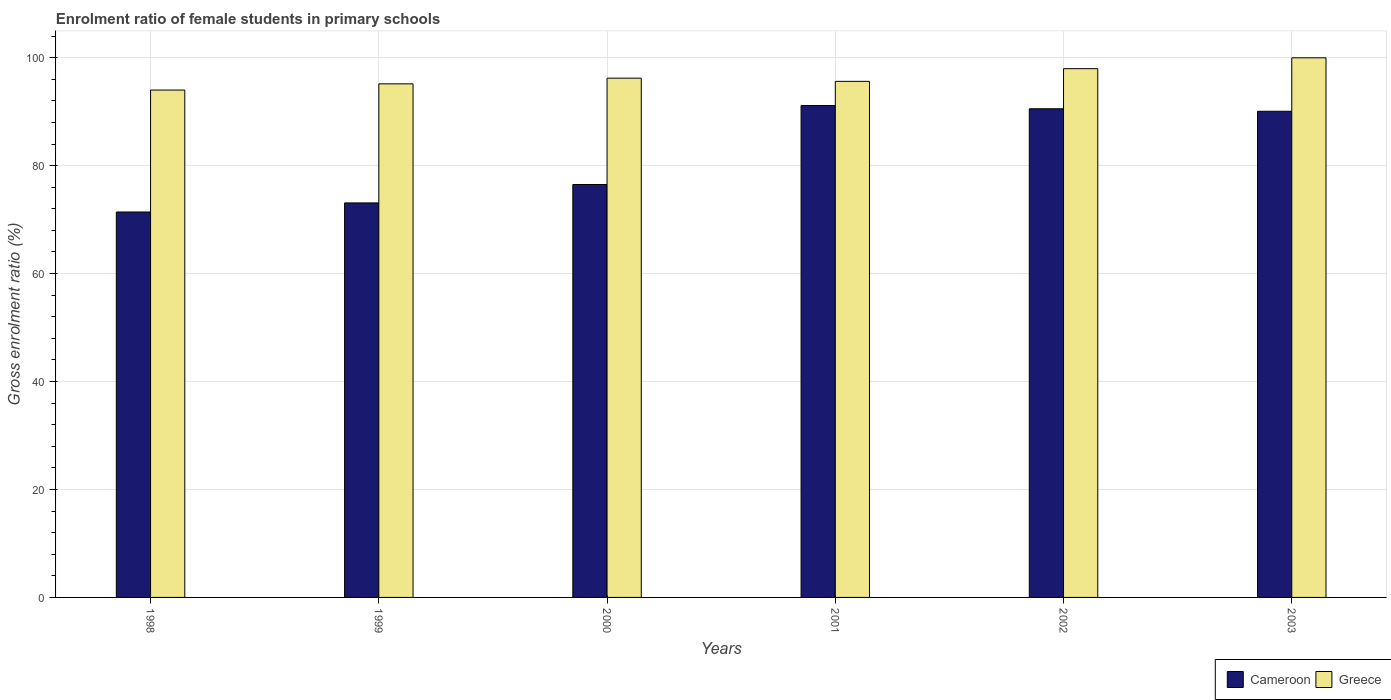Are the number of bars on each tick of the X-axis equal?
Offer a terse response. Yes. How many bars are there on the 2nd tick from the left?
Your response must be concise. 2. What is the label of the 2nd group of bars from the left?
Your answer should be compact. 1999. What is the enrolment ratio of female students in primary schools in Greece in 1998?
Offer a very short reply. 94. Across all years, what is the maximum enrolment ratio of female students in primary schools in Cameroon?
Offer a very short reply. 91.14. Across all years, what is the minimum enrolment ratio of female students in primary schools in Greece?
Provide a succinct answer. 94. In which year was the enrolment ratio of female students in primary schools in Cameroon maximum?
Ensure brevity in your answer.  2001. What is the total enrolment ratio of female students in primary schools in Cameroon in the graph?
Your response must be concise. 492.74. What is the difference between the enrolment ratio of female students in primary schools in Cameroon in 2000 and that in 2003?
Offer a very short reply. -13.57. What is the difference between the enrolment ratio of female students in primary schools in Greece in 2002 and the enrolment ratio of female students in primary schools in Cameroon in 1999?
Provide a succinct answer. 24.87. What is the average enrolment ratio of female students in primary schools in Greece per year?
Ensure brevity in your answer.  96.49. In the year 1999, what is the difference between the enrolment ratio of female students in primary schools in Cameroon and enrolment ratio of female students in primary schools in Greece?
Give a very brief answer. -22.06. In how many years, is the enrolment ratio of female students in primary schools in Cameroon greater than 28 %?
Your answer should be very brief. 6. What is the ratio of the enrolment ratio of female students in primary schools in Greece in 2002 to that in 2003?
Provide a short and direct response. 0.98. Is the enrolment ratio of female students in primary schools in Greece in 2001 less than that in 2002?
Offer a very short reply. Yes. Is the difference between the enrolment ratio of female students in primary schools in Cameroon in 1999 and 2002 greater than the difference between the enrolment ratio of female students in primary schools in Greece in 1999 and 2002?
Provide a short and direct response. No. What is the difference between the highest and the second highest enrolment ratio of female students in primary schools in Greece?
Keep it short and to the point. 2.01. What is the difference between the highest and the lowest enrolment ratio of female students in primary schools in Cameroon?
Make the answer very short. 19.73. What does the 1st bar from the left in 2000 represents?
Provide a short and direct response. Cameroon. What does the 2nd bar from the right in 2002 represents?
Give a very brief answer. Cameroon. Are the values on the major ticks of Y-axis written in scientific E-notation?
Offer a terse response. No. Does the graph contain any zero values?
Give a very brief answer. No. Where does the legend appear in the graph?
Your answer should be compact. Bottom right. How many legend labels are there?
Provide a short and direct response. 2. What is the title of the graph?
Ensure brevity in your answer.  Enrolment ratio of female students in primary schools. What is the label or title of the Y-axis?
Make the answer very short. Gross enrolment ratio (%). What is the Gross enrolment ratio (%) of Cameroon in 1998?
Your response must be concise. 71.41. What is the Gross enrolment ratio (%) in Greece in 1998?
Your answer should be very brief. 94. What is the Gross enrolment ratio (%) in Cameroon in 1999?
Your response must be concise. 73.09. What is the Gross enrolment ratio (%) in Greece in 1999?
Make the answer very short. 95.15. What is the Gross enrolment ratio (%) in Cameroon in 2000?
Your answer should be very brief. 76.5. What is the Gross enrolment ratio (%) of Greece in 2000?
Your answer should be very brief. 96.21. What is the Gross enrolment ratio (%) in Cameroon in 2001?
Your answer should be very brief. 91.14. What is the Gross enrolment ratio (%) in Greece in 2001?
Offer a terse response. 95.61. What is the Gross enrolment ratio (%) in Cameroon in 2002?
Your answer should be compact. 90.53. What is the Gross enrolment ratio (%) of Greece in 2002?
Offer a terse response. 97.96. What is the Gross enrolment ratio (%) of Cameroon in 2003?
Keep it short and to the point. 90.07. What is the Gross enrolment ratio (%) in Greece in 2003?
Make the answer very short. 99.97. Across all years, what is the maximum Gross enrolment ratio (%) of Cameroon?
Ensure brevity in your answer.  91.14. Across all years, what is the maximum Gross enrolment ratio (%) in Greece?
Your answer should be very brief. 99.97. Across all years, what is the minimum Gross enrolment ratio (%) of Cameroon?
Your answer should be very brief. 71.41. Across all years, what is the minimum Gross enrolment ratio (%) in Greece?
Keep it short and to the point. 94. What is the total Gross enrolment ratio (%) of Cameroon in the graph?
Offer a terse response. 492.74. What is the total Gross enrolment ratio (%) in Greece in the graph?
Ensure brevity in your answer.  578.91. What is the difference between the Gross enrolment ratio (%) in Cameroon in 1998 and that in 1999?
Your answer should be compact. -1.68. What is the difference between the Gross enrolment ratio (%) in Greece in 1998 and that in 1999?
Provide a short and direct response. -1.15. What is the difference between the Gross enrolment ratio (%) in Cameroon in 1998 and that in 2000?
Offer a terse response. -5.09. What is the difference between the Gross enrolment ratio (%) of Greece in 1998 and that in 2000?
Your answer should be very brief. -2.2. What is the difference between the Gross enrolment ratio (%) in Cameroon in 1998 and that in 2001?
Offer a terse response. -19.73. What is the difference between the Gross enrolment ratio (%) of Greece in 1998 and that in 2001?
Make the answer very short. -1.61. What is the difference between the Gross enrolment ratio (%) in Cameroon in 1998 and that in 2002?
Offer a very short reply. -19.12. What is the difference between the Gross enrolment ratio (%) of Greece in 1998 and that in 2002?
Your answer should be very brief. -3.96. What is the difference between the Gross enrolment ratio (%) of Cameroon in 1998 and that in 2003?
Keep it short and to the point. -18.66. What is the difference between the Gross enrolment ratio (%) of Greece in 1998 and that in 2003?
Give a very brief answer. -5.97. What is the difference between the Gross enrolment ratio (%) in Cameroon in 1999 and that in 2000?
Provide a succinct answer. -3.41. What is the difference between the Gross enrolment ratio (%) in Greece in 1999 and that in 2000?
Provide a succinct answer. -1.05. What is the difference between the Gross enrolment ratio (%) in Cameroon in 1999 and that in 2001?
Provide a short and direct response. -18.05. What is the difference between the Gross enrolment ratio (%) of Greece in 1999 and that in 2001?
Offer a terse response. -0.46. What is the difference between the Gross enrolment ratio (%) of Cameroon in 1999 and that in 2002?
Offer a very short reply. -17.44. What is the difference between the Gross enrolment ratio (%) of Greece in 1999 and that in 2002?
Ensure brevity in your answer.  -2.81. What is the difference between the Gross enrolment ratio (%) of Cameroon in 1999 and that in 2003?
Your answer should be very brief. -16.98. What is the difference between the Gross enrolment ratio (%) in Greece in 1999 and that in 2003?
Your response must be concise. -4.82. What is the difference between the Gross enrolment ratio (%) in Cameroon in 2000 and that in 2001?
Provide a succinct answer. -14.64. What is the difference between the Gross enrolment ratio (%) in Greece in 2000 and that in 2001?
Give a very brief answer. 0.59. What is the difference between the Gross enrolment ratio (%) in Cameroon in 2000 and that in 2002?
Offer a very short reply. -14.03. What is the difference between the Gross enrolment ratio (%) in Greece in 2000 and that in 2002?
Provide a short and direct response. -1.76. What is the difference between the Gross enrolment ratio (%) of Cameroon in 2000 and that in 2003?
Offer a very short reply. -13.57. What is the difference between the Gross enrolment ratio (%) in Greece in 2000 and that in 2003?
Make the answer very short. -3.77. What is the difference between the Gross enrolment ratio (%) of Cameroon in 2001 and that in 2002?
Provide a succinct answer. 0.61. What is the difference between the Gross enrolment ratio (%) of Greece in 2001 and that in 2002?
Offer a terse response. -2.35. What is the difference between the Gross enrolment ratio (%) of Cameroon in 2001 and that in 2003?
Provide a succinct answer. 1.07. What is the difference between the Gross enrolment ratio (%) in Greece in 2001 and that in 2003?
Provide a succinct answer. -4.36. What is the difference between the Gross enrolment ratio (%) of Cameroon in 2002 and that in 2003?
Ensure brevity in your answer.  0.46. What is the difference between the Gross enrolment ratio (%) in Greece in 2002 and that in 2003?
Your answer should be very brief. -2.01. What is the difference between the Gross enrolment ratio (%) in Cameroon in 1998 and the Gross enrolment ratio (%) in Greece in 1999?
Keep it short and to the point. -23.74. What is the difference between the Gross enrolment ratio (%) in Cameroon in 1998 and the Gross enrolment ratio (%) in Greece in 2000?
Offer a terse response. -24.79. What is the difference between the Gross enrolment ratio (%) in Cameroon in 1998 and the Gross enrolment ratio (%) in Greece in 2001?
Your response must be concise. -24.2. What is the difference between the Gross enrolment ratio (%) in Cameroon in 1998 and the Gross enrolment ratio (%) in Greece in 2002?
Provide a succinct answer. -26.55. What is the difference between the Gross enrolment ratio (%) in Cameroon in 1998 and the Gross enrolment ratio (%) in Greece in 2003?
Offer a terse response. -28.56. What is the difference between the Gross enrolment ratio (%) of Cameroon in 1999 and the Gross enrolment ratio (%) of Greece in 2000?
Provide a short and direct response. -23.11. What is the difference between the Gross enrolment ratio (%) in Cameroon in 1999 and the Gross enrolment ratio (%) in Greece in 2001?
Your answer should be compact. -22.52. What is the difference between the Gross enrolment ratio (%) in Cameroon in 1999 and the Gross enrolment ratio (%) in Greece in 2002?
Keep it short and to the point. -24.87. What is the difference between the Gross enrolment ratio (%) in Cameroon in 1999 and the Gross enrolment ratio (%) in Greece in 2003?
Keep it short and to the point. -26.88. What is the difference between the Gross enrolment ratio (%) in Cameroon in 2000 and the Gross enrolment ratio (%) in Greece in 2001?
Give a very brief answer. -19.11. What is the difference between the Gross enrolment ratio (%) in Cameroon in 2000 and the Gross enrolment ratio (%) in Greece in 2002?
Provide a succinct answer. -21.46. What is the difference between the Gross enrolment ratio (%) in Cameroon in 2000 and the Gross enrolment ratio (%) in Greece in 2003?
Provide a succinct answer. -23.47. What is the difference between the Gross enrolment ratio (%) of Cameroon in 2001 and the Gross enrolment ratio (%) of Greece in 2002?
Offer a terse response. -6.83. What is the difference between the Gross enrolment ratio (%) in Cameroon in 2001 and the Gross enrolment ratio (%) in Greece in 2003?
Keep it short and to the point. -8.84. What is the difference between the Gross enrolment ratio (%) in Cameroon in 2002 and the Gross enrolment ratio (%) in Greece in 2003?
Make the answer very short. -9.44. What is the average Gross enrolment ratio (%) in Cameroon per year?
Keep it short and to the point. 82.12. What is the average Gross enrolment ratio (%) in Greece per year?
Give a very brief answer. 96.49. In the year 1998, what is the difference between the Gross enrolment ratio (%) of Cameroon and Gross enrolment ratio (%) of Greece?
Provide a short and direct response. -22.59. In the year 1999, what is the difference between the Gross enrolment ratio (%) in Cameroon and Gross enrolment ratio (%) in Greece?
Ensure brevity in your answer.  -22.06. In the year 2000, what is the difference between the Gross enrolment ratio (%) of Cameroon and Gross enrolment ratio (%) of Greece?
Make the answer very short. -19.7. In the year 2001, what is the difference between the Gross enrolment ratio (%) in Cameroon and Gross enrolment ratio (%) in Greece?
Give a very brief answer. -4.47. In the year 2002, what is the difference between the Gross enrolment ratio (%) in Cameroon and Gross enrolment ratio (%) in Greece?
Offer a very short reply. -7.43. In the year 2003, what is the difference between the Gross enrolment ratio (%) in Cameroon and Gross enrolment ratio (%) in Greece?
Make the answer very short. -9.9. What is the ratio of the Gross enrolment ratio (%) of Cameroon in 1998 to that in 1999?
Provide a short and direct response. 0.98. What is the ratio of the Gross enrolment ratio (%) in Greece in 1998 to that in 1999?
Offer a terse response. 0.99. What is the ratio of the Gross enrolment ratio (%) of Cameroon in 1998 to that in 2000?
Offer a terse response. 0.93. What is the ratio of the Gross enrolment ratio (%) in Greece in 1998 to that in 2000?
Ensure brevity in your answer.  0.98. What is the ratio of the Gross enrolment ratio (%) in Cameroon in 1998 to that in 2001?
Ensure brevity in your answer.  0.78. What is the ratio of the Gross enrolment ratio (%) of Greece in 1998 to that in 2001?
Your answer should be compact. 0.98. What is the ratio of the Gross enrolment ratio (%) in Cameroon in 1998 to that in 2002?
Offer a very short reply. 0.79. What is the ratio of the Gross enrolment ratio (%) in Greece in 1998 to that in 2002?
Offer a terse response. 0.96. What is the ratio of the Gross enrolment ratio (%) of Cameroon in 1998 to that in 2003?
Your response must be concise. 0.79. What is the ratio of the Gross enrolment ratio (%) in Greece in 1998 to that in 2003?
Your answer should be compact. 0.94. What is the ratio of the Gross enrolment ratio (%) of Cameroon in 1999 to that in 2000?
Ensure brevity in your answer.  0.96. What is the ratio of the Gross enrolment ratio (%) in Greece in 1999 to that in 2000?
Provide a succinct answer. 0.99. What is the ratio of the Gross enrolment ratio (%) of Cameroon in 1999 to that in 2001?
Provide a succinct answer. 0.8. What is the ratio of the Gross enrolment ratio (%) of Cameroon in 1999 to that in 2002?
Your answer should be very brief. 0.81. What is the ratio of the Gross enrolment ratio (%) in Greece in 1999 to that in 2002?
Provide a short and direct response. 0.97. What is the ratio of the Gross enrolment ratio (%) of Cameroon in 1999 to that in 2003?
Make the answer very short. 0.81. What is the ratio of the Gross enrolment ratio (%) in Greece in 1999 to that in 2003?
Your response must be concise. 0.95. What is the ratio of the Gross enrolment ratio (%) in Cameroon in 2000 to that in 2001?
Offer a terse response. 0.84. What is the ratio of the Gross enrolment ratio (%) in Greece in 2000 to that in 2001?
Provide a short and direct response. 1.01. What is the ratio of the Gross enrolment ratio (%) of Cameroon in 2000 to that in 2002?
Give a very brief answer. 0.84. What is the ratio of the Gross enrolment ratio (%) of Greece in 2000 to that in 2002?
Your answer should be very brief. 0.98. What is the ratio of the Gross enrolment ratio (%) in Cameroon in 2000 to that in 2003?
Offer a very short reply. 0.85. What is the ratio of the Gross enrolment ratio (%) in Greece in 2000 to that in 2003?
Offer a terse response. 0.96. What is the ratio of the Gross enrolment ratio (%) in Cameroon in 2001 to that in 2003?
Make the answer very short. 1.01. What is the ratio of the Gross enrolment ratio (%) in Greece in 2001 to that in 2003?
Offer a very short reply. 0.96. What is the ratio of the Gross enrolment ratio (%) of Greece in 2002 to that in 2003?
Your answer should be compact. 0.98. What is the difference between the highest and the second highest Gross enrolment ratio (%) of Cameroon?
Your answer should be very brief. 0.61. What is the difference between the highest and the second highest Gross enrolment ratio (%) of Greece?
Your answer should be very brief. 2.01. What is the difference between the highest and the lowest Gross enrolment ratio (%) of Cameroon?
Ensure brevity in your answer.  19.73. What is the difference between the highest and the lowest Gross enrolment ratio (%) in Greece?
Ensure brevity in your answer.  5.97. 